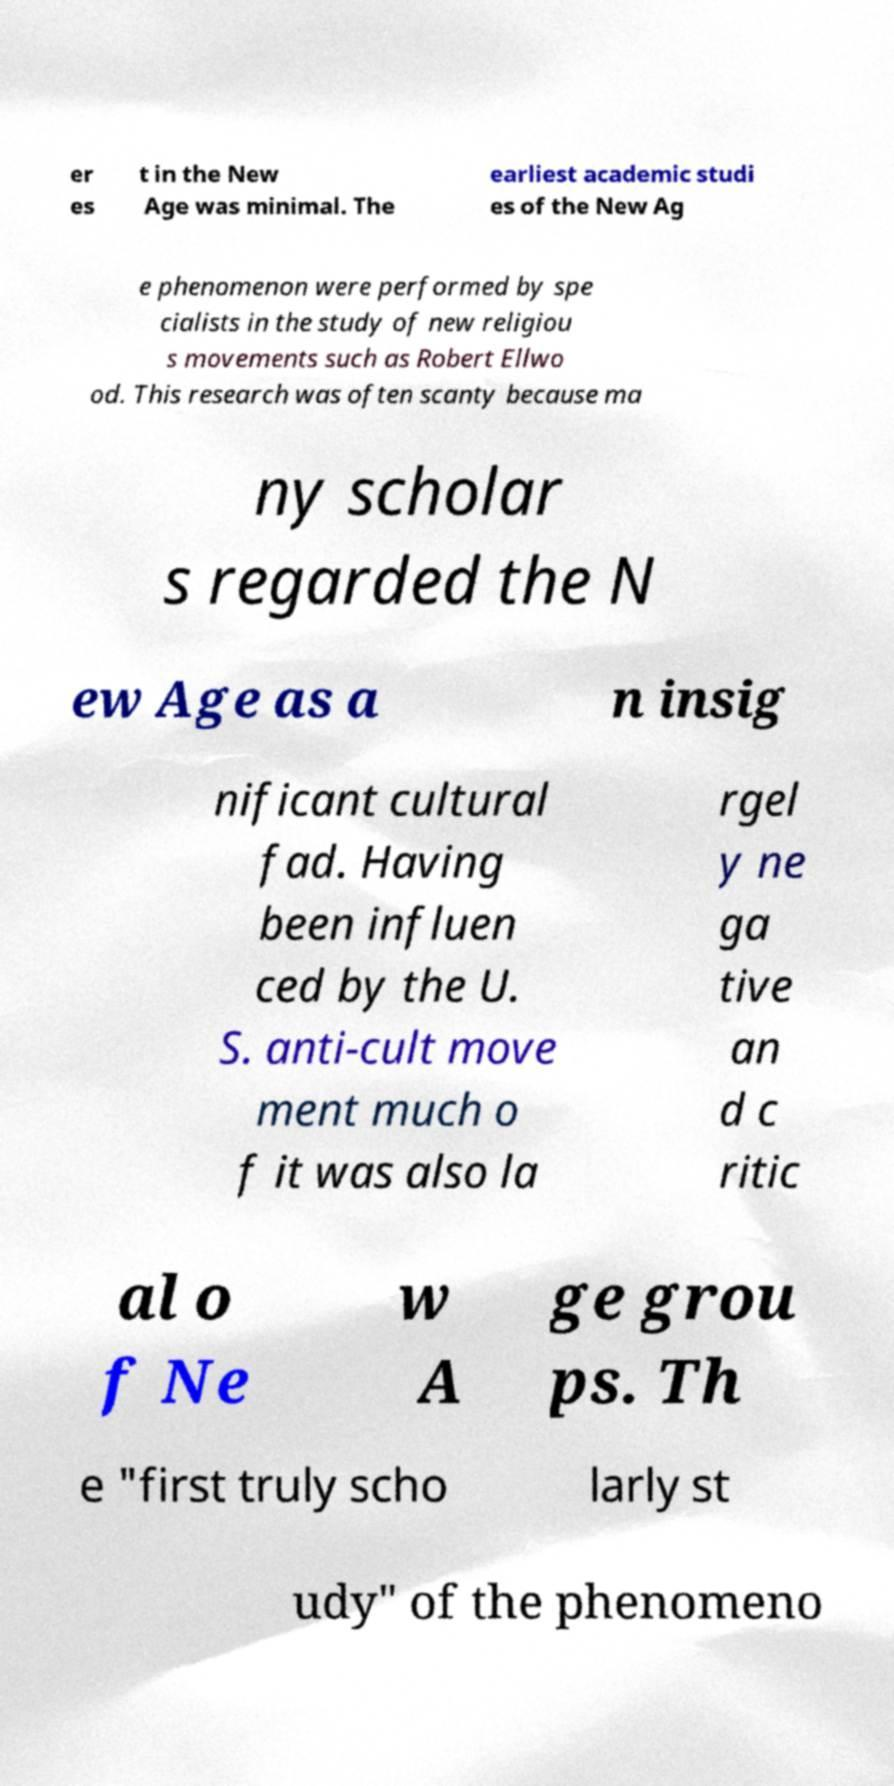What messages or text are displayed in this image? I need them in a readable, typed format. er es t in the New Age was minimal. The earliest academic studi es of the New Ag e phenomenon were performed by spe cialists in the study of new religiou s movements such as Robert Ellwo od. This research was often scanty because ma ny scholar s regarded the N ew Age as a n insig nificant cultural fad. Having been influen ced by the U. S. anti-cult move ment much o f it was also la rgel y ne ga tive an d c ritic al o f Ne w A ge grou ps. Th e "first truly scho larly st udy" of the phenomeno 